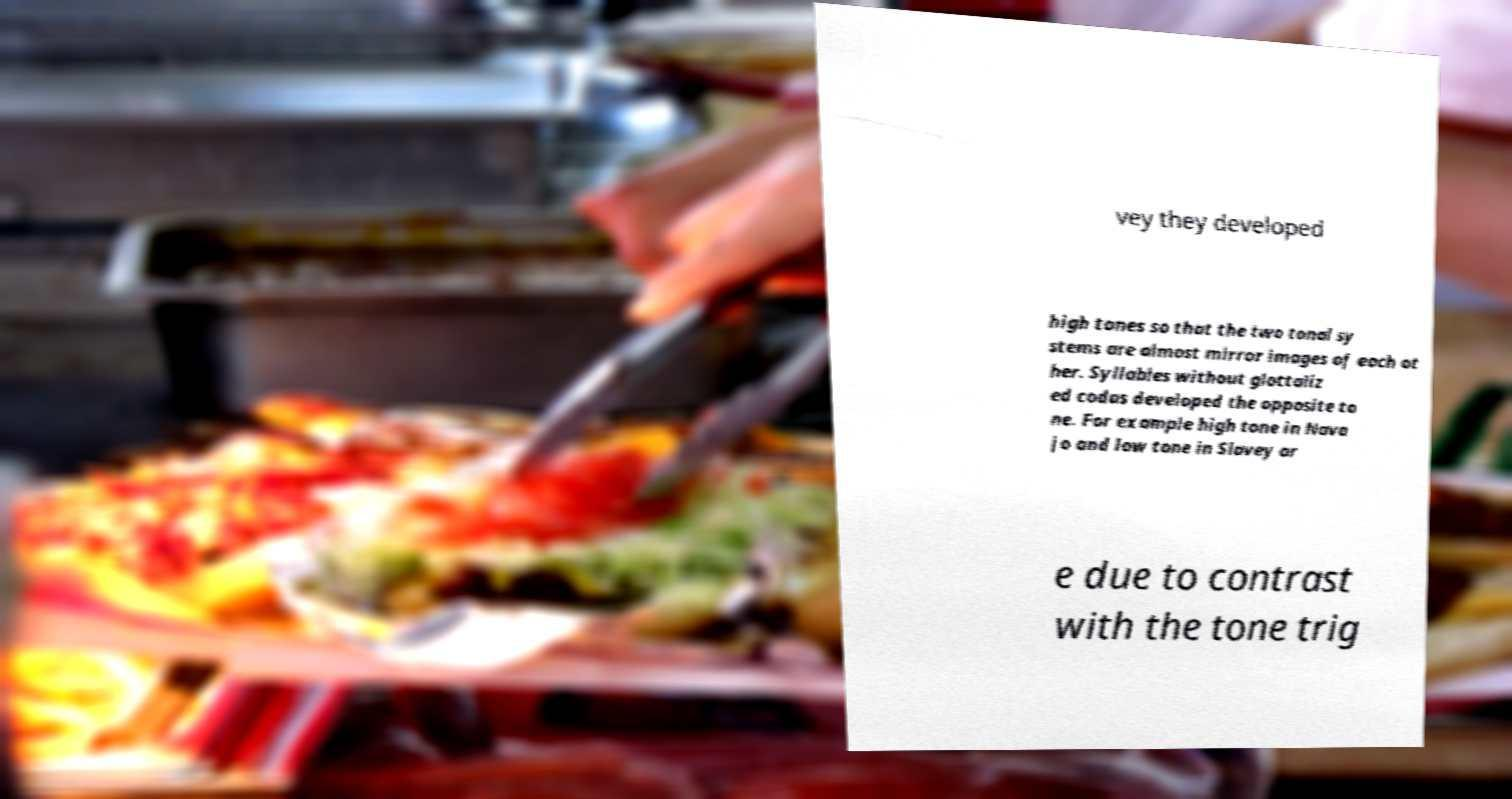Could you assist in decoding the text presented in this image and type it out clearly? vey they developed high tones so that the two tonal sy stems are almost mirror images of each ot her. Syllables without glottaliz ed codas developed the opposite to ne. For example high tone in Nava jo and low tone in Slavey ar e due to contrast with the tone trig 